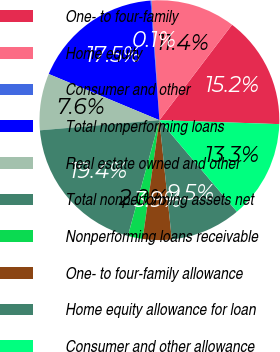Convert chart. <chart><loc_0><loc_0><loc_500><loc_500><pie_chart><fcel>One- to four-family<fcel>Home equity<fcel>Consumer and other<fcel>Total nonperforming loans<fcel>Real estate owned and other<fcel>Total nonperforming assets net<fcel>Nonperforming loans receivable<fcel>One- to four-family allowance<fcel>Home equity allowance for loan<fcel>Consumer and other allowance<nl><fcel>15.17%<fcel>11.41%<fcel>0.12%<fcel>17.54%<fcel>7.64%<fcel>19.42%<fcel>2.0%<fcel>3.88%<fcel>9.53%<fcel>13.29%<nl></chart> 